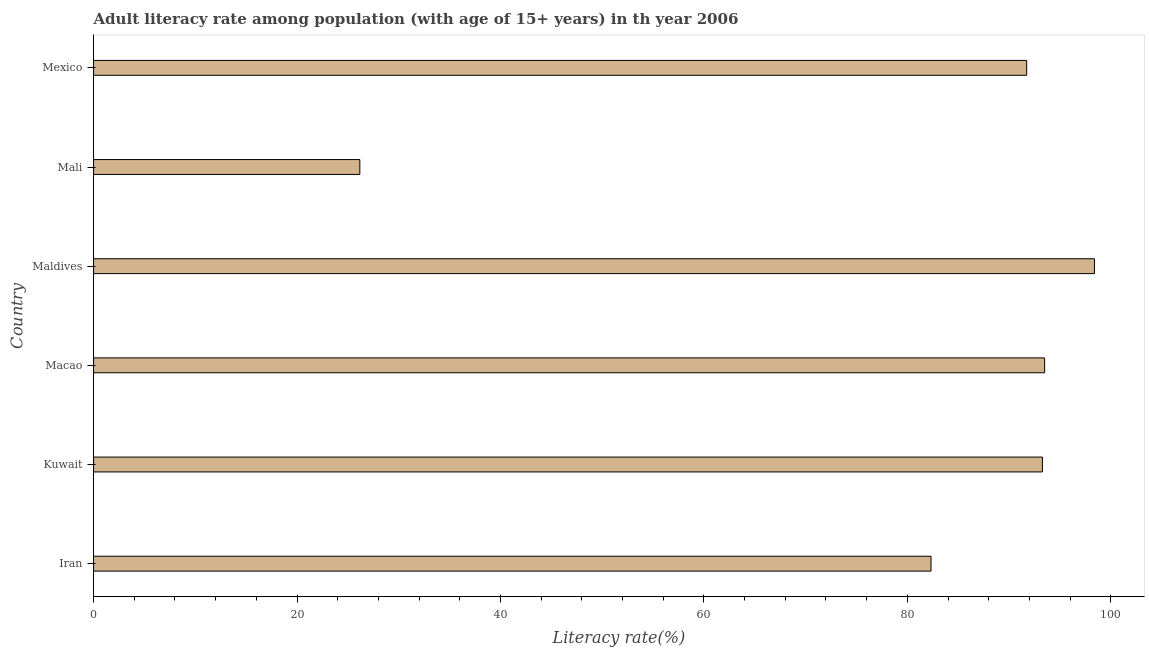Does the graph contain any zero values?
Ensure brevity in your answer.  No. Does the graph contain grids?
Make the answer very short. No. What is the title of the graph?
Provide a succinct answer. Adult literacy rate among population (with age of 15+ years) in th year 2006. What is the label or title of the X-axis?
Your answer should be compact. Literacy rate(%). What is the adult literacy rate in Mali?
Make the answer very short. 26.18. Across all countries, what is the maximum adult literacy rate?
Provide a succinct answer. 98.4. Across all countries, what is the minimum adult literacy rate?
Your answer should be very brief. 26.18. In which country was the adult literacy rate maximum?
Keep it short and to the point. Maldives. In which country was the adult literacy rate minimum?
Offer a terse response. Mali. What is the sum of the adult literacy rate?
Offer a very short reply. 485.42. What is the difference between the adult literacy rate in Iran and Maldives?
Provide a short and direct response. -16.07. What is the average adult literacy rate per country?
Provide a short and direct response. 80.9. What is the median adult literacy rate?
Offer a terse response. 92.51. In how many countries, is the adult literacy rate greater than 56 %?
Keep it short and to the point. 5. What is the ratio of the adult literacy rate in Kuwait to that in Maldives?
Provide a succinct answer. 0.95. Is the difference between the adult literacy rate in Maldives and Mexico greater than the difference between any two countries?
Provide a succinct answer. No. What is the difference between the highest and the second highest adult literacy rate?
Give a very brief answer. 4.9. Is the sum of the adult literacy rate in Kuwait and Mexico greater than the maximum adult literacy rate across all countries?
Make the answer very short. Yes. What is the difference between the highest and the lowest adult literacy rate?
Keep it short and to the point. 72.22. In how many countries, is the adult literacy rate greater than the average adult literacy rate taken over all countries?
Keep it short and to the point. 5. How many bars are there?
Your response must be concise. 6. Are all the bars in the graph horizontal?
Offer a very short reply. Yes. What is the difference between two consecutive major ticks on the X-axis?
Your answer should be very brief. 20. Are the values on the major ticks of X-axis written in scientific E-notation?
Keep it short and to the point. No. What is the Literacy rate(%) of Iran?
Your response must be concise. 82.33. What is the Literacy rate(%) of Kuwait?
Keep it short and to the point. 93.28. What is the Literacy rate(%) in Macao?
Offer a terse response. 93.5. What is the Literacy rate(%) of Maldives?
Offer a terse response. 98.4. What is the Literacy rate(%) of Mali?
Ensure brevity in your answer.  26.18. What is the Literacy rate(%) in Mexico?
Provide a succinct answer. 91.73. What is the difference between the Literacy rate(%) in Iran and Kuwait?
Provide a succinct answer. -10.95. What is the difference between the Literacy rate(%) in Iran and Macao?
Make the answer very short. -11.17. What is the difference between the Literacy rate(%) in Iran and Maldives?
Offer a terse response. -16.07. What is the difference between the Literacy rate(%) in Iran and Mali?
Provide a short and direct response. 56.15. What is the difference between the Literacy rate(%) in Iran and Mexico?
Your response must be concise. -9.4. What is the difference between the Literacy rate(%) in Kuwait and Macao?
Provide a succinct answer. -0.22. What is the difference between the Literacy rate(%) in Kuwait and Maldives?
Offer a terse response. -5.12. What is the difference between the Literacy rate(%) in Kuwait and Mali?
Offer a terse response. 67.11. What is the difference between the Literacy rate(%) in Kuwait and Mexico?
Offer a terse response. 1.55. What is the difference between the Literacy rate(%) in Macao and Maldives?
Ensure brevity in your answer.  -4.9. What is the difference between the Literacy rate(%) in Macao and Mali?
Keep it short and to the point. 67.32. What is the difference between the Literacy rate(%) in Macao and Mexico?
Offer a very short reply. 1.77. What is the difference between the Literacy rate(%) in Maldives and Mali?
Make the answer very short. 72.22. What is the difference between the Literacy rate(%) in Maldives and Mexico?
Provide a succinct answer. 6.66. What is the difference between the Literacy rate(%) in Mali and Mexico?
Provide a succinct answer. -65.56. What is the ratio of the Literacy rate(%) in Iran to that in Kuwait?
Your response must be concise. 0.88. What is the ratio of the Literacy rate(%) in Iran to that in Macao?
Keep it short and to the point. 0.88. What is the ratio of the Literacy rate(%) in Iran to that in Maldives?
Ensure brevity in your answer.  0.84. What is the ratio of the Literacy rate(%) in Iran to that in Mali?
Your response must be concise. 3.15. What is the ratio of the Literacy rate(%) in Iran to that in Mexico?
Make the answer very short. 0.9. What is the ratio of the Literacy rate(%) in Kuwait to that in Macao?
Give a very brief answer. 1. What is the ratio of the Literacy rate(%) in Kuwait to that in Maldives?
Keep it short and to the point. 0.95. What is the ratio of the Literacy rate(%) in Kuwait to that in Mali?
Keep it short and to the point. 3.56. What is the ratio of the Literacy rate(%) in Macao to that in Maldives?
Your answer should be very brief. 0.95. What is the ratio of the Literacy rate(%) in Macao to that in Mali?
Provide a succinct answer. 3.57. What is the ratio of the Literacy rate(%) in Maldives to that in Mali?
Your answer should be very brief. 3.76. What is the ratio of the Literacy rate(%) in Maldives to that in Mexico?
Your answer should be very brief. 1.07. What is the ratio of the Literacy rate(%) in Mali to that in Mexico?
Offer a terse response. 0.28. 